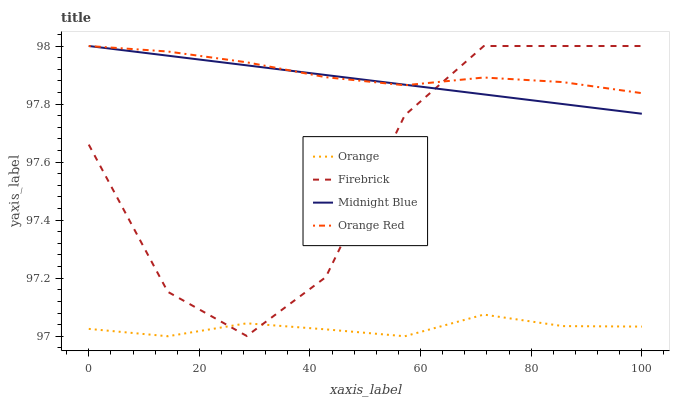Does Orange have the minimum area under the curve?
Answer yes or no. Yes. Does Orange Red have the maximum area under the curve?
Answer yes or no. Yes. Does Firebrick have the minimum area under the curve?
Answer yes or no. No. Does Firebrick have the maximum area under the curve?
Answer yes or no. No. Is Midnight Blue the smoothest?
Answer yes or no. Yes. Is Firebrick the roughest?
Answer yes or no. Yes. Is Firebrick the smoothest?
Answer yes or no. No. Is Midnight Blue the roughest?
Answer yes or no. No. Does Orange have the lowest value?
Answer yes or no. Yes. Does Firebrick have the lowest value?
Answer yes or no. No. Does Orange Red have the highest value?
Answer yes or no. Yes. Is Orange less than Orange Red?
Answer yes or no. Yes. Is Orange Red greater than Orange?
Answer yes or no. Yes. Does Orange Red intersect Midnight Blue?
Answer yes or no. Yes. Is Orange Red less than Midnight Blue?
Answer yes or no. No. Is Orange Red greater than Midnight Blue?
Answer yes or no. No. Does Orange intersect Orange Red?
Answer yes or no. No. 